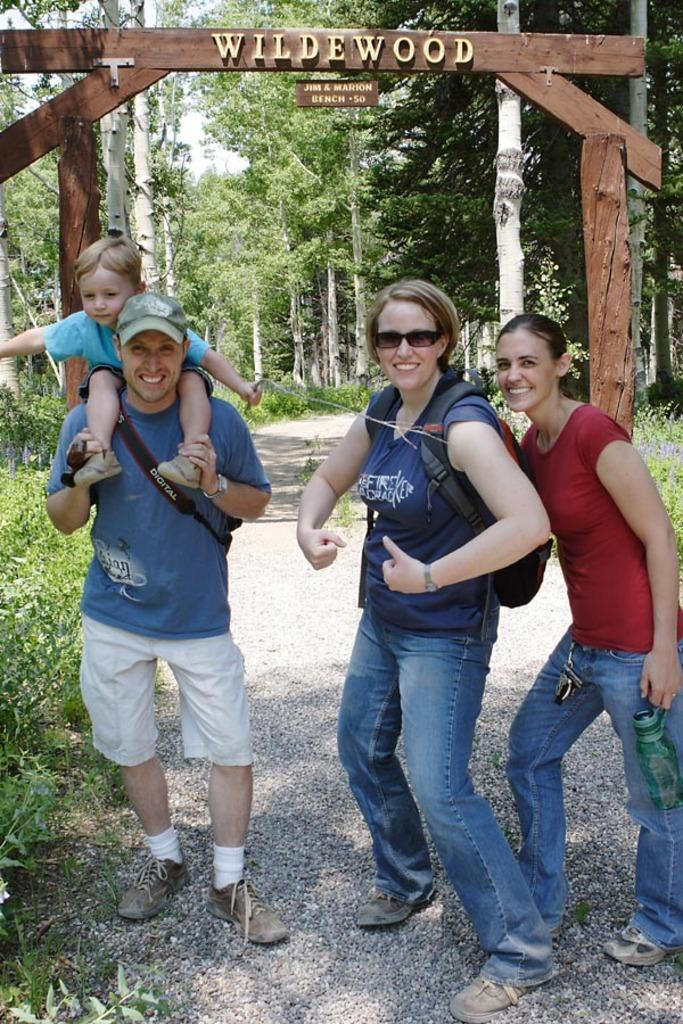Who is present in the image? There is a family in the image. What are the family members doing? The family members are standing and smiling. Where is the family located in the image? The family is standing on a road. What is behind the family in the image? There is a wooden arch behind the family. What type of vegetation can be seen in the image? There are trees and plants in the image. What type of milk is being served at the committee meeting in the image? There is no committee meeting or milk present in the image; it features a family standing on a road. What type of eggnog is being prepared by the family in the image? There is no eggnog or preparation activity present in the image; the family members are simply standing and smiling. 